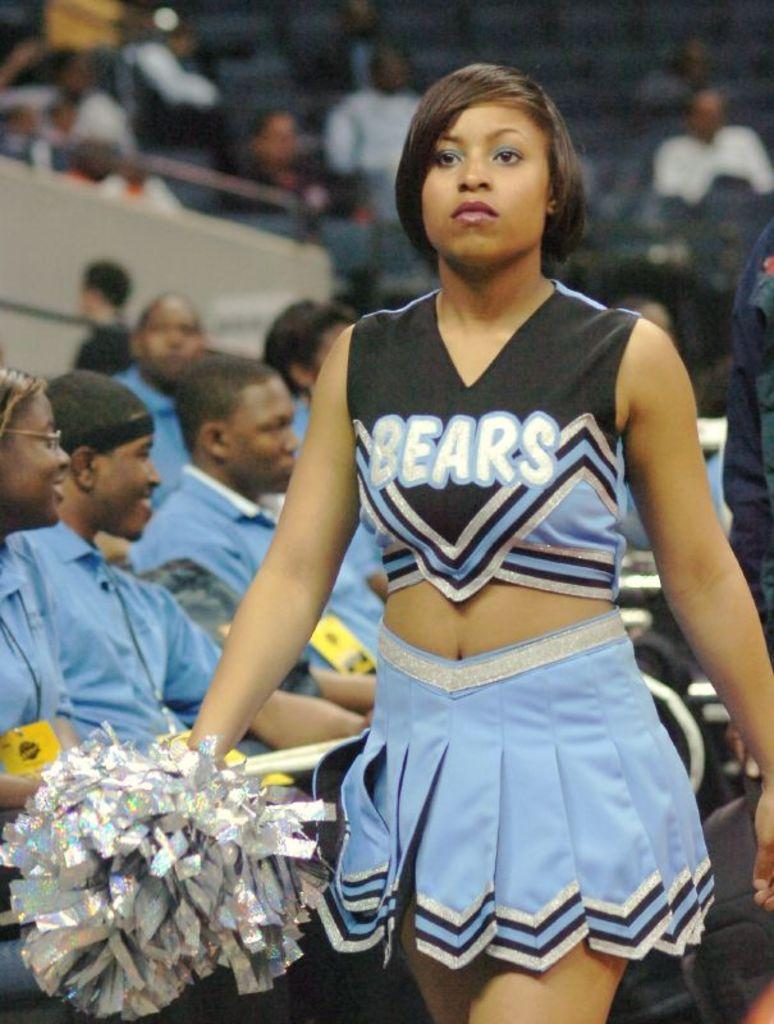<image>
Present a compact description of the photo's key features. A cheerleader wears a uniform with the word Bears on it. 